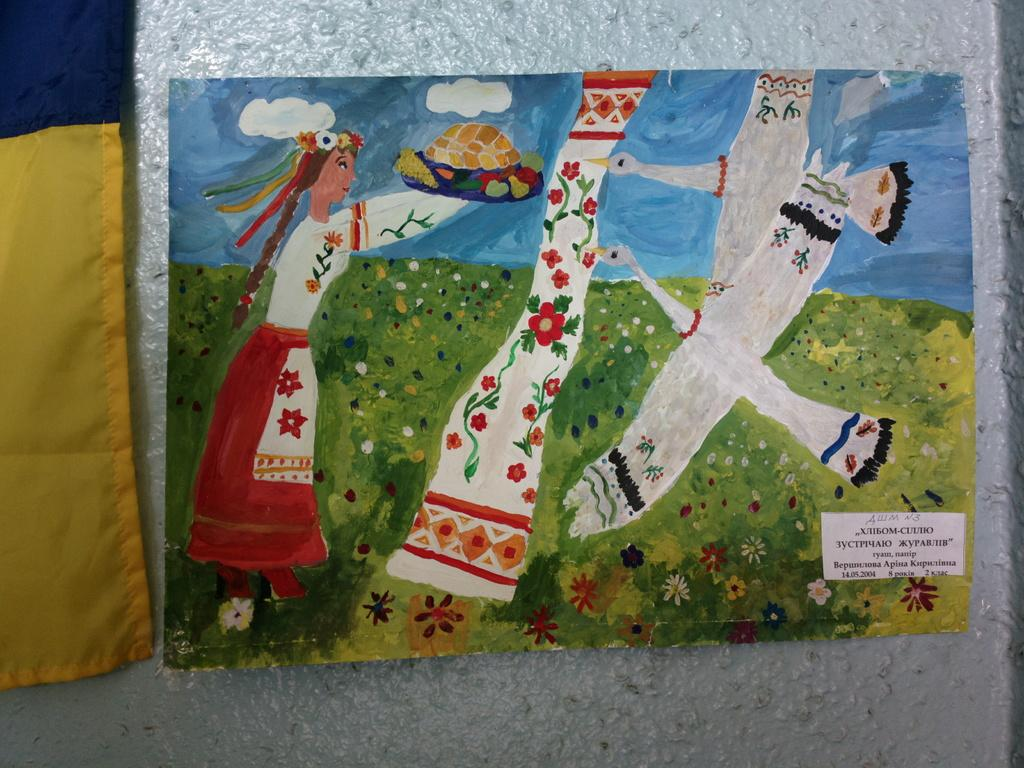What type of artwork is depicted in the image? The image is a painting. What can be seen on the left side of the painting? There is a cloth on the left side of the painting. Who or what is the main subject in the painting? There is a girl in the painting. Are there any animals present in the painting? Yes, there are two birds in the painting. What type of jewel is the girl wearing in the painting? There is no mention of a jewel in the painting; the girl is not depicted wearing any jewelry. 